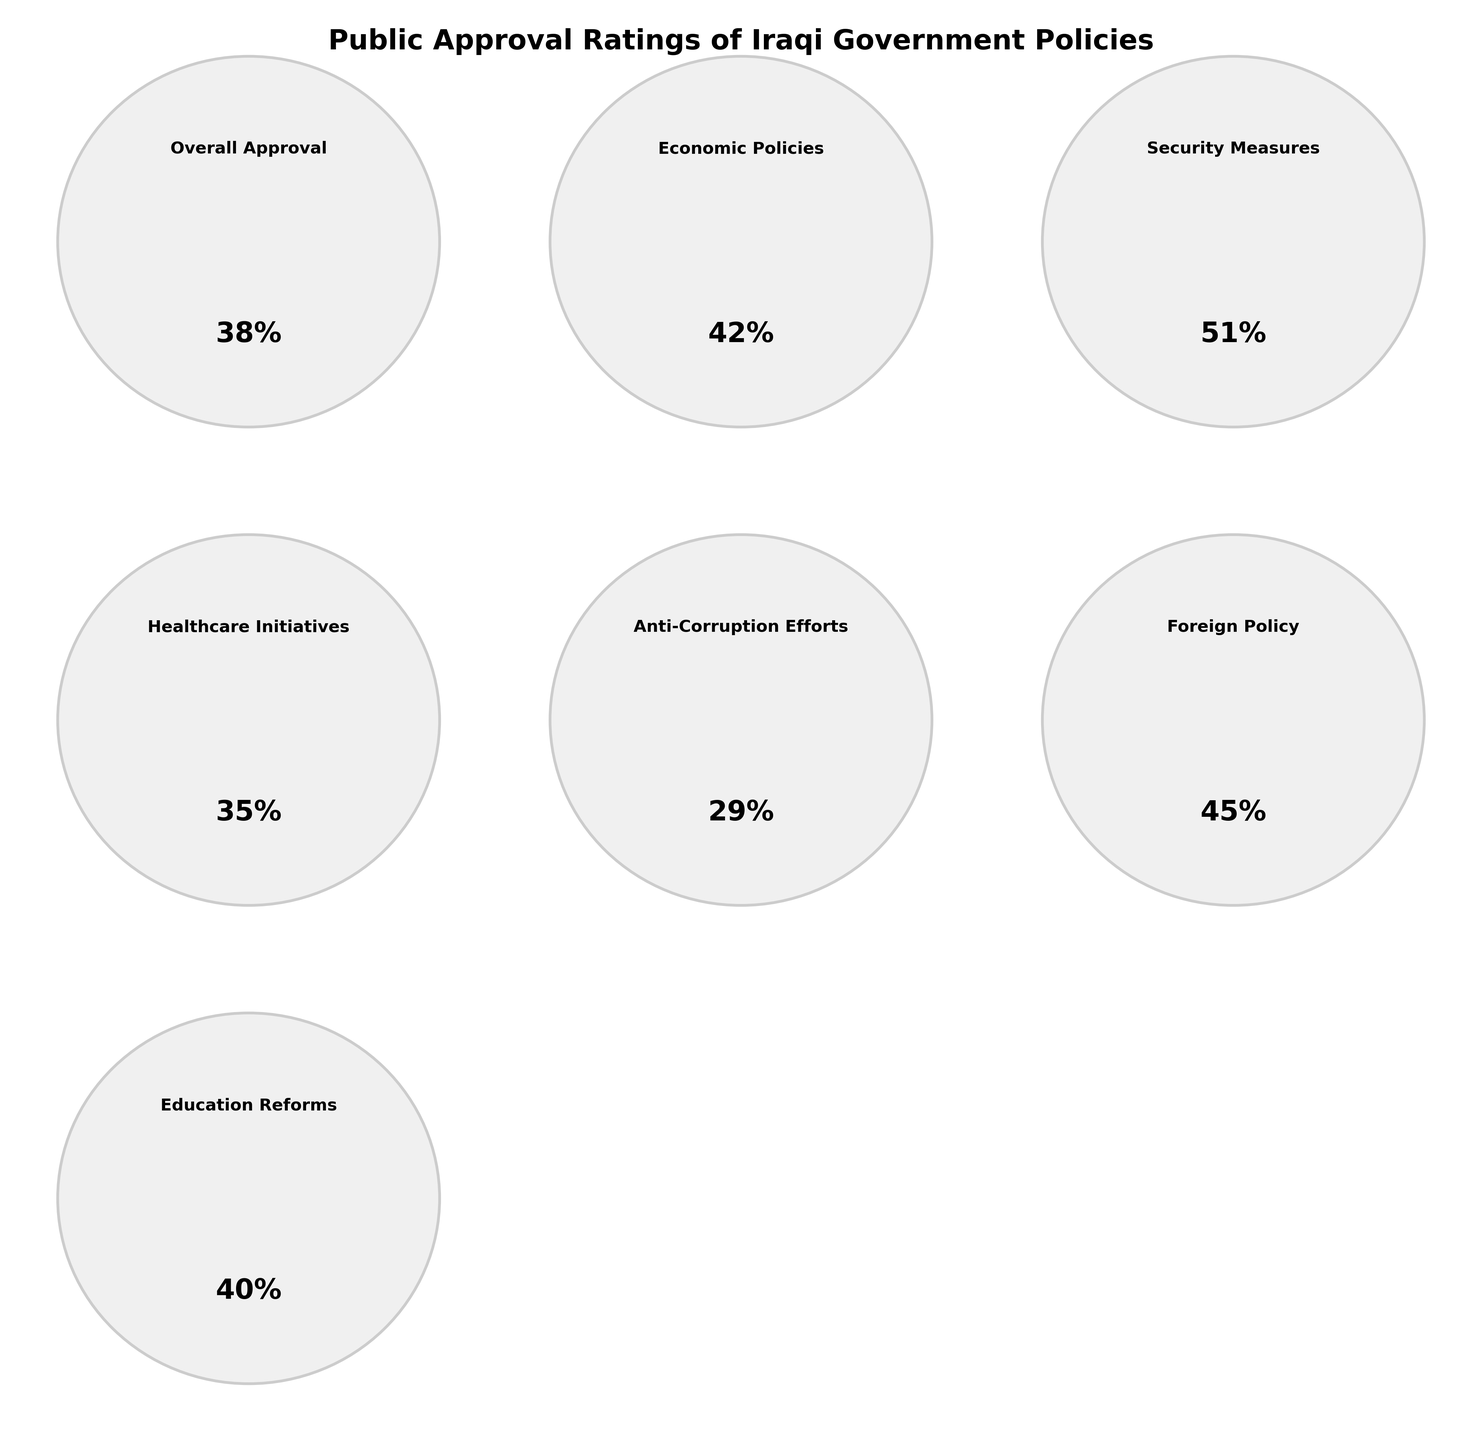What is the overall approval rating for Iraqi government policies? Look at the gauge chart labeled "Overall Approval"; the gauge indicates 38%.
Answer: 38% Which category has the highest approval rating? Check each of the gauge charts and find the category with the highest percentage. The category "Security Measures" has the highest approval rating at 51%.
Answer: Security Measures What is the difference in approval rating between Education Reforms and Healthcare Initiatives? The Education Reforms gauge shows 40% and the Healthcare Initiatives gauge shows 35%. Calculate the difference: 40% - 35% = 5%.
Answer: 5% Which categories have an approval rating of more than 40%? Identify all categories with approval ratings above 40%. Economic Policies (42%), Security Measures (51%), and Foreign Policy (45%) meet this criterion.
Answer: Economic Policies, Security Measures, Foreign Policy What is the median approval rating among all categories? List all the approval percentages: 38, 42, 51, 35, 29, 45, 40. Order them: 29, 35, 38, 40, 42, 45, 51. The middle value is the median: 40%.
Answer: 40% What is the average approval rating across all categories? Add all percentages (38 + 42 + 51 + 35 + 29 + 45 + 40) which equals 280, then divide by the number of categories which is 7. 280 / 7 = 40%.
Answer: 40% Which category has the lowest approval rating? Check each gauge chart to find the category with the lowest percentage. The category "Anti-Corruption Efforts" has the lowest approval rating at 29%.
Answer: Anti-Corruption Efforts Between Foreign Policy and Economic Policies, which has a higher approval rating and by how much? The Foreign Policy gauge shows 45% and Economic Policies gauge shows 42%. Calculate the difference: 45% - 42% = 3%.
Answer: Foreign Policy, 3% What is the total approval rating for Economic Policies, Education Reforms, and Healthcare Initiatives combined? Add the approval percentages of Economic Policies (42%), Education Reforms (40%), and Healthcare Initiatives (35%): 42 + 40 + 35 = 117%.
Answer: 117% How many categories have an approval rating below the overall approval rating? The overall approval rating is 38%. Check each category: Anti-Corruption Efforts (29%), Healthcare Initiatives (35%). There are 2 categories below 38%.
Answer: 2 